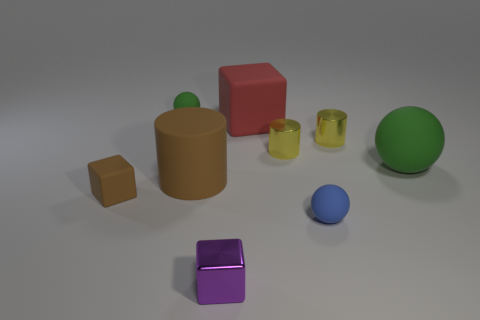What material is the small thing that is the same color as the large rubber ball?
Ensure brevity in your answer.  Rubber. Do the ball left of the brown rubber cylinder and the big matte cylinder have the same color?
Ensure brevity in your answer.  No. There is a large ball that is made of the same material as the large brown cylinder; what color is it?
Provide a short and direct response. Green. Do the brown cylinder and the purple metal object have the same size?
Your answer should be very brief. No. What material is the red cube?
Provide a succinct answer. Rubber. There is a brown object that is the same size as the red block; what material is it?
Provide a short and direct response. Rubber. Is there a brown cylinder that has the same size as the red rubber cube?
Offer a very short reply. Yes. Is the number of tiny purple metallic objects that are to the left of the purple block the same as the number of green objects to the left of the brown cylinder?
Offer a terse response. No. Is the number of green shiny objects greater than the number of brown rubber objects?
Offer a very short reply. No. How many shiny objects are either small blocks or green spheres?
Your answer should be compact. 1. 